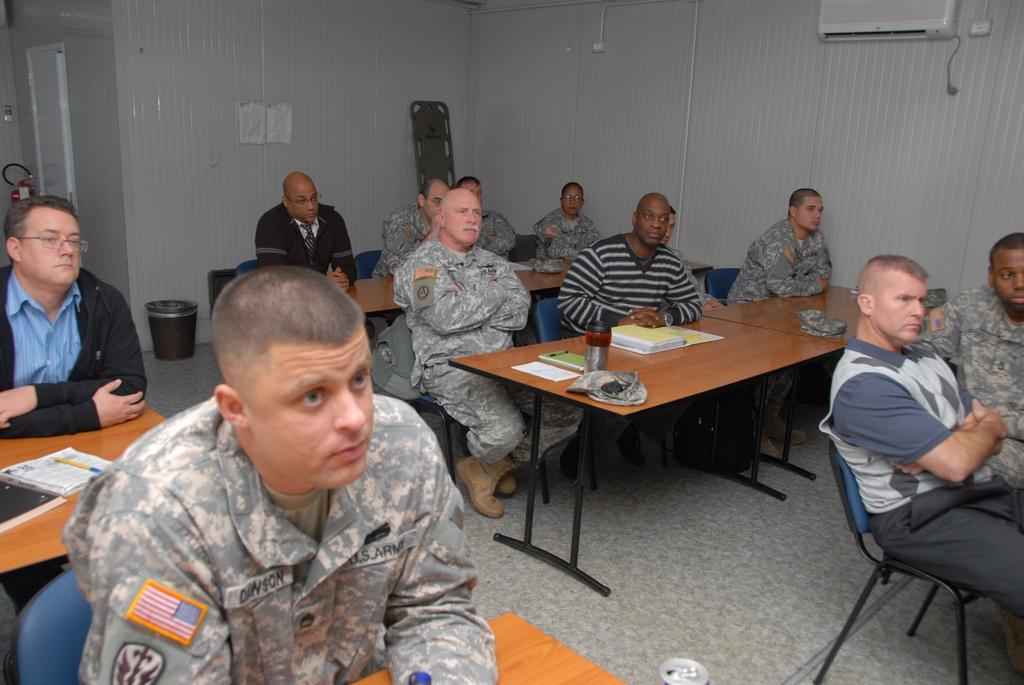Please provide a concise description of this image. This picture is clicked inside a conference room and front we see a man in the uniform sitting on the chair. Behind him, we see the other man wearing black jacket and spectacles. right of him, we see many people sitting on the chair and even we see tables. On table we can see bottle, pen, book. Behind this people, we see a wall which is white in color and on right top we see air conditioner and on the left top, we see fire extinguisher. 